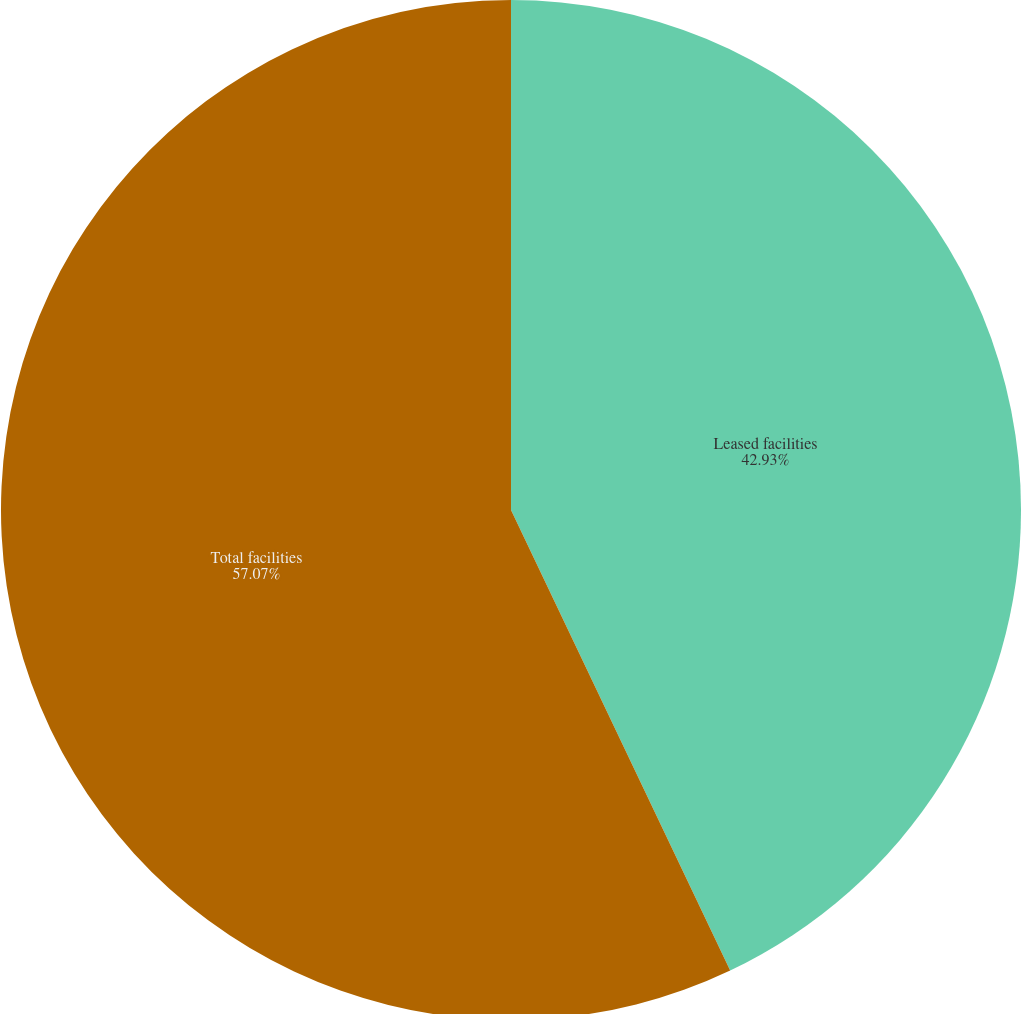<chart> <loc_0><loc_0><loc_500><loc_500><pie_chart><fcel>Leased facilities<fcel>Total facilities<nl><fcel>42.93%<fcel>57.07%<nl></chart> 